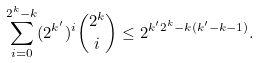<formula> <loc_0><loc_0><loc_500><loc_500>\sum _ { i = 0 } ^ { 2 ^ { k } - k } ( 2 ^ { k ^ { \prime } } ) ^ { i } \binom { 2 ^ { k } } { i } \leq 2 ^ { k ^ { \prime } 2 ^ { k } - k ( k ^ { \prime } - k - 1 ) } .</formula> 